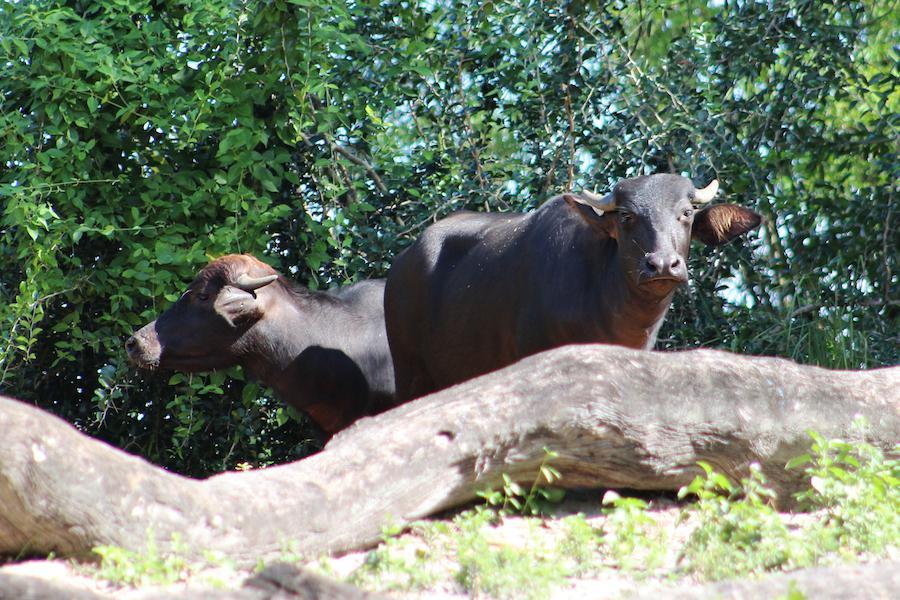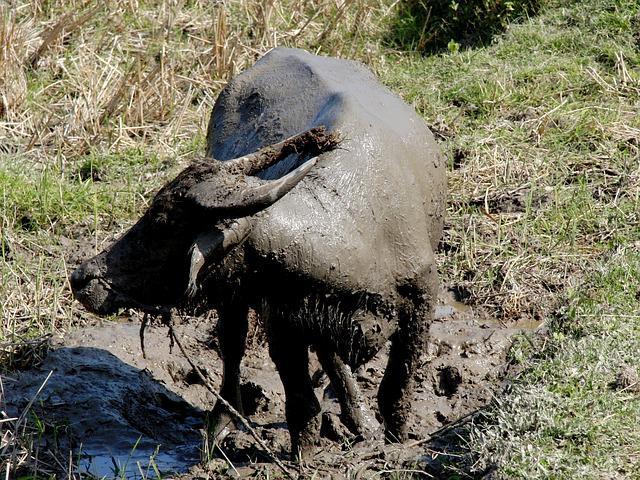The first image is the image on the left, the second image is the image on the right. Assess this claim about the two images: "There are exactly two animals in the image on the left.". Correct or not? Answer yes or no. Yes. 